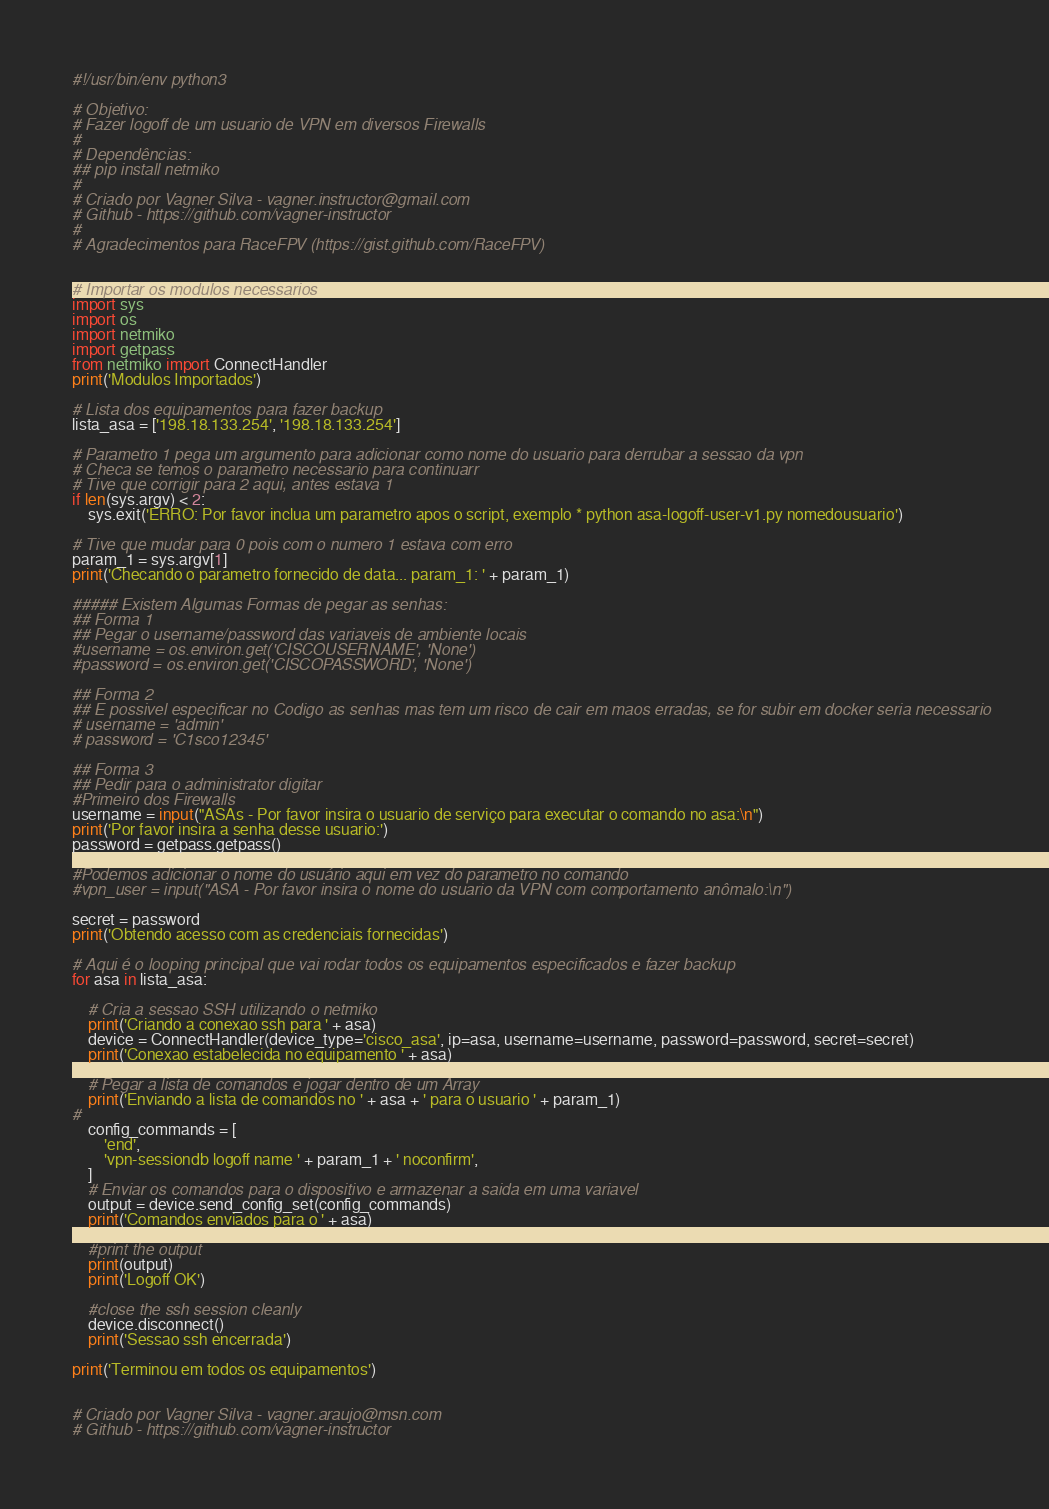<code> <loc_0><loc_0><loc_500><loc_500><_Python_>#!/usr/bin/env python3

# Objetivo:
# Fazer logoff de um usuario de VPN em diversos Firewalls
#
# Dependências:
## pip install netmiko
#
# Criado por Vagner Silva - vagner.instructor@gmail.com
# Github - https://github.com/vagner-instructor
#
# Agradecimentos para RaceFPV (https://gist.github.com/RaceFPV)


# Importar os modulos necessarios
import sys
import os
import netmiko
import getpass
from netmiko import ConnectHandler
print('Modulos Importados')

# Lista dos equipamentos para fazer backup
lista_asa = ['198.18.133.254', '198.18.133.254']

# Parametro 1 pega um argumento para adicionar como nome do usuario para derrubar a sessao da vpn
# Checa se temos o parametro necessario para continuarr
# Tive que corrigir para 2 aqui, antes estava 1
if len(sys.argv) < 2:
    sys.exit('ERRO: Por favor inclua um parametro apos o script, exemplo * python asa-logoff-user-v1.py nomedousuario')
    
# Tive que mudar para 0 pois com o numero 1 estava com erro
param_1 = sys.argv[1]
print('Checando o parametro fornecido de data... param_1: ' + param_1)

##### Existem Algumas Formas de pegar as senhas:
## Forma 1
## Pegar o username/password das variaveis de ambiente locais
#username = os.environ.get('CISCOUSERNAME', 'None')
#password = os.environ.get('CISCOPASSWORD', 'None')

## Forma 2
## E possivel especificar no Codigo as senhas mas tem um risco de cair em maos erradas, se for subir em docker seria necessario
# username = 'admin'
# password = 'C1sco12345'

## Forma 3
## Pedir para o administrator digitar
#Primeiro dos Firewalls
username = input("ASAs - Por favor insira o usuario de serviço para executar o comando no asa:\n")
print('Por favor insira a senha desse usuario:')
password = getpass.getpass()

#Podemos adicionar o nome do usuário aqui em vez do parametro no comando
#vpn_user = input("ASA - Por favor insira o nome do usuario da VPN com comportamento anômalo:\n")

secret = password
print('Obtendo acesso com as credenciais fornecidas')

# Aqui é o looping principal que vai rodar todos os equipamentos especificados e fazer backup
for asa in lista_asa:

    # Cria a sessao SSH utilizando o netmiko
    print('Criando a conexao ssh para ' + asa)
    device = ConnectHandler(device_type='cisco_asa', ip=asa, username=username, password=password, secret=secret)
    print('Conexao estabelecida no equipamento ' + asa)

    # Pegar a lista de comandos e jogar dentro de um Array
    print('Enviando a lista de comandos no ' + asa + ' para o usuario ' + param_1)
#
    config_commands = [
        'end',
        'vpn-sessiondb logoff name ' + param_1 + ' noconfirm',
    ]
    # Enviar os comandos para o dispositivo e armazenar a saida em uma variavel
    output = device.send_config_set(config_commands)
    print('Comandos enviados para o ' + asa)

    #print the output
    print(output)
    print('Logoff OK')

    #close the ssh session cleanly
    device.disconnect()
    print('Sessao ssh encerrada')

print('Terminou em todos os equipamentos')


# Criado por Vagner Silva - vagner.araujo@msn.com
# Github - https://github.com/vagner-instructor</code> 